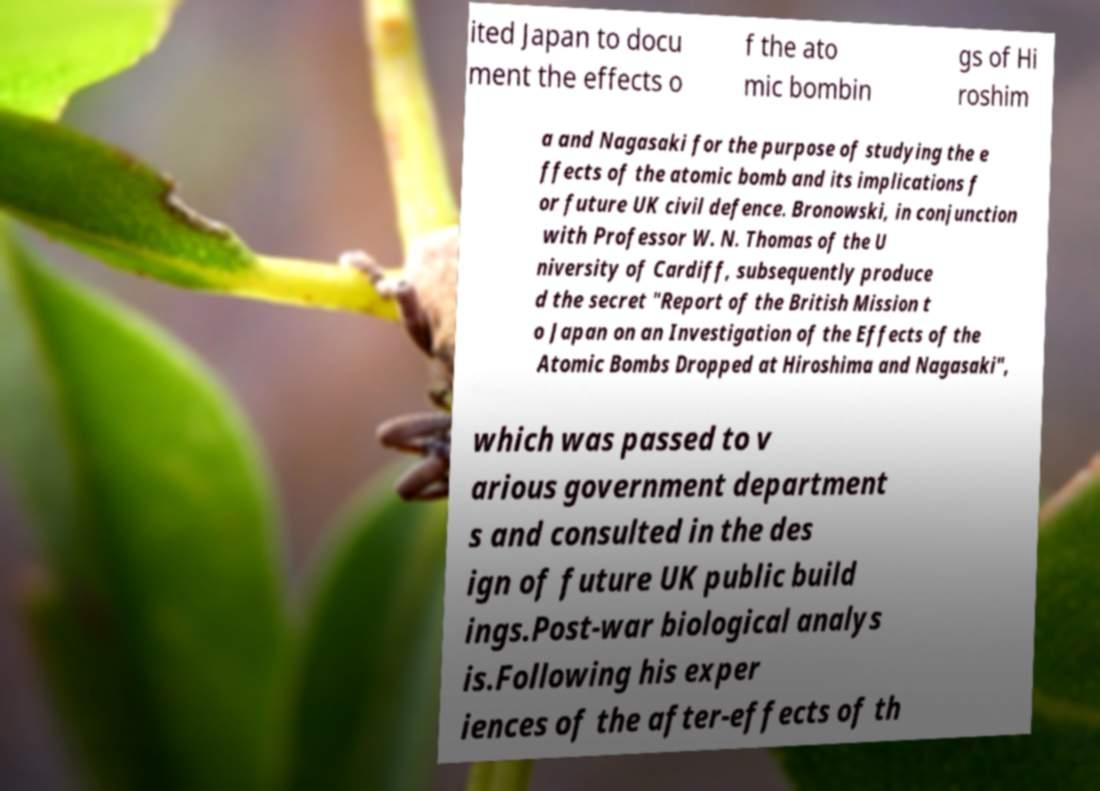Can you read and provide the text displayed in the image?This photo seems to have some interesting text. Can you extract and type it out for me? ited Japan to docu ment the effects o f the ato mic bombin gs of Hi roshim a and Nagasaki for the purpose of studying the e ffects of the atomic bomb and its implications f or future UK civil defence. Bronowski, in conjunction with Professor W. N. Thomas of the U niversity of Cardiff, subsequently produce d the secret "Report of the British Mission t o Japan on an Investigation of the Effects of the Atomic Bombs Dropped at Hiroshima and Nagasaki", which was passed to v arious government department s and consulted in the des ign of future UK public build ings.Post-war biological analys is.Following his exper iences of the after-effects of th 